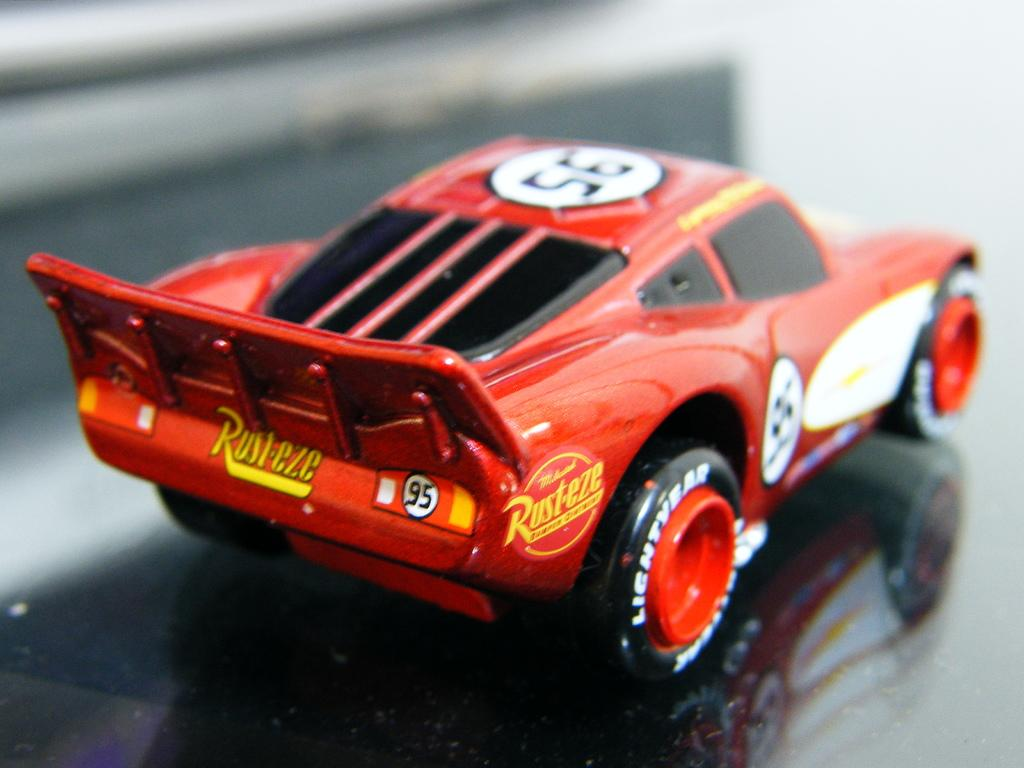What type of toy is present in the image? There is a toy car in the image. Can you describe any additional features related to the toy car in the image? Yes, there is a reflection of the toy car in the image. What type of game is being played with the toy car in the image? There is no indication in the image that a game is being played with the toy car. Can you see any rail or train tracks associated with the toy car in the image? There is no rail or train tracks visible in the image; it only features a toy car and its reflection. 